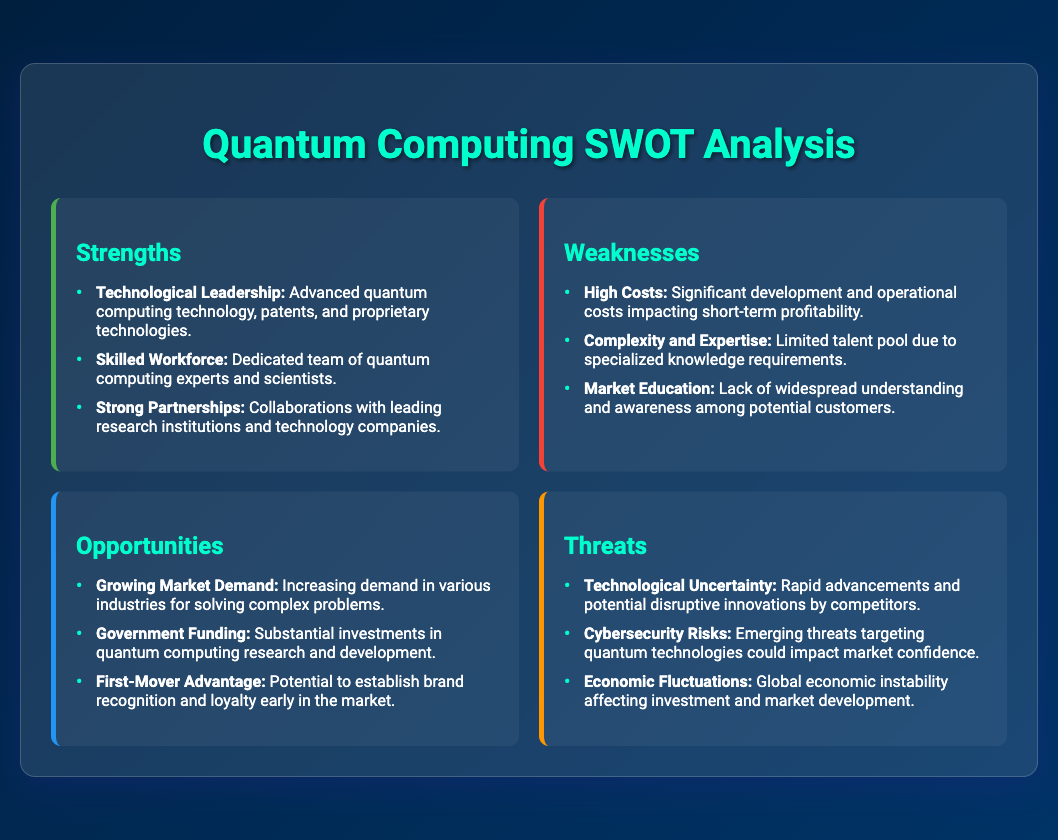What are two strengths listed? The strengths include "Technological Leadership" and "Skilled Workforce," highlighting key advantages of the company.
Answer: Technological Leadership, Skilled Workforce What is a weakness related to market understanding? The weakness mentions "Lack of widespread understanding and awareness among potential customers," indicating a challenge in market education.
Answer: Market Education What is the opportunity related to government support? The opportunity states "Substantial investments in quantum computing research and development" indicating government involvement supports market growth.
Answer: Government Funding What is one of the identified threats affecting confidence? The threat emphasizes "Emerging threats targeting quantum technologies could impact market confidence," focusing on cybersecurity risks.
Answer: Cybersecurity Risks How many strengths are listed in the document? There are three strengths listed in the SWOT analysis, showcasing the company’s advantages.
Answer: 3 What is a potential benefit of being an early player in the market? The document mentions a "Potential to establish brand recognition and loyalty early in the market" as a significant advantage.
Answer: First-Mover Advantage Which item indicates potential financial risk due to external factors? The item "Global economic instability affecting investment and market development" points to economic fluctuations as a threat.
Answer: Economic Fluctuations What specific area is highlighted as needing more talent? The item "Limited talent pool due to specialized knowledge requirements" reflects the need for expertise in quantum technologies.
Answer: Complexity and Expertise 